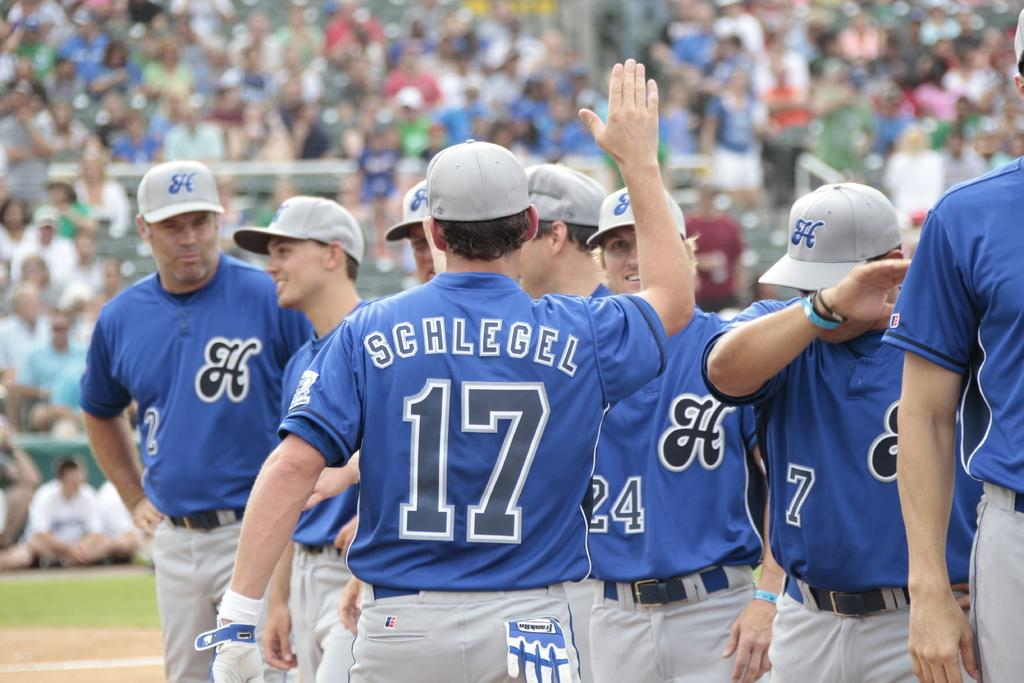<image>
Describe the image concisely. Player number 17 whose name isSchlegel is going for a high five. 